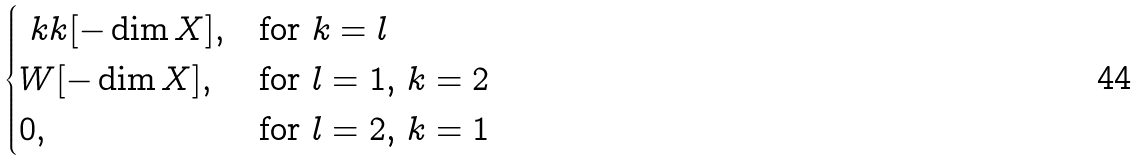<formula> <loc_0><loc_0><loc_500><loc_500>\begin{cases} \ k k [ - \dim X ] , & \text {for $k=l$} \\ W [ - \dim X ] , & \text {for $l=1$, $k=2$} \\ 0 , & \text {for $l=2$, $k=1$} \end{cases}</formula> 